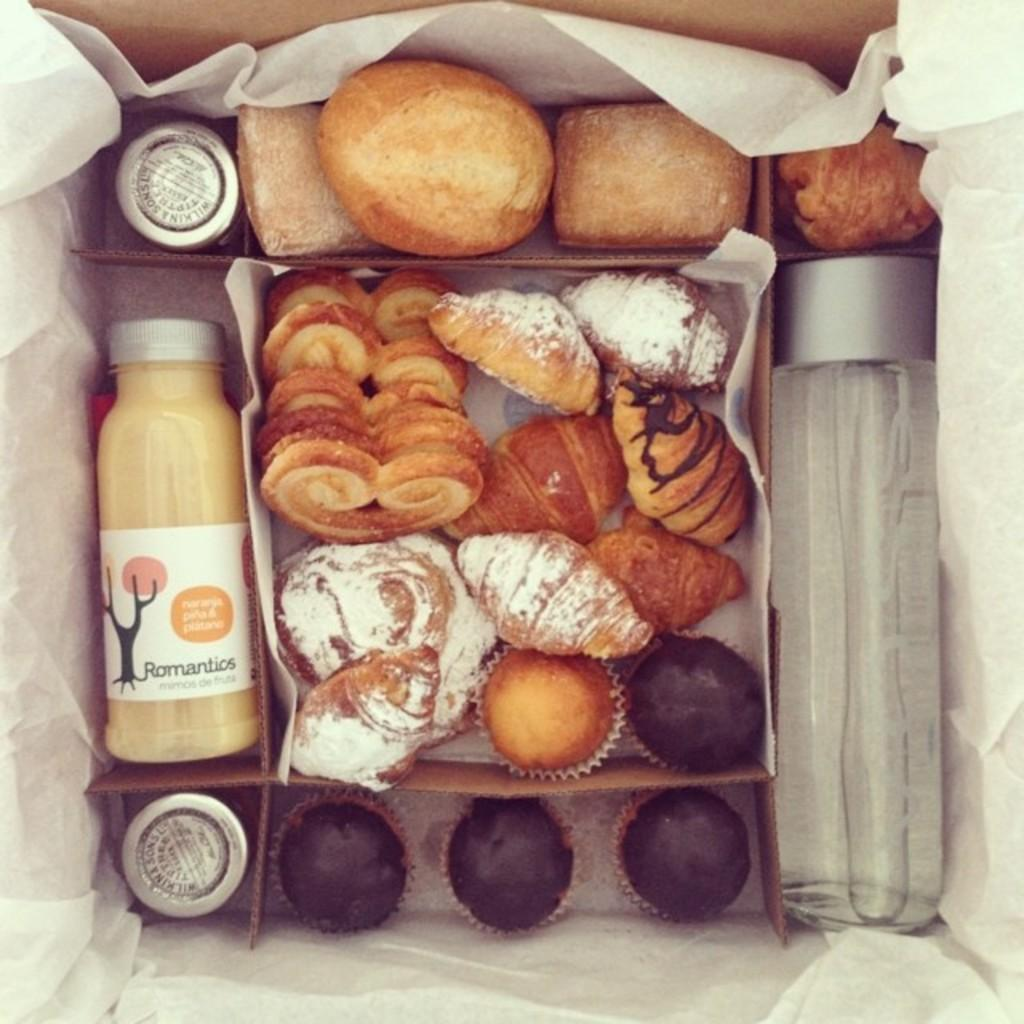What is the main object in the image? There is a cardboard box in the image. What is inside the box? The box contains tissue paper, a bottle of juice, a water bottle, cupcakes, and puffs. What type of food items are present in the box? There are cupcakes and puffs, which are food items, in the box. How does the wound heal in the image? There is no wound present in the image; it features a cardboard box with various items inside. 